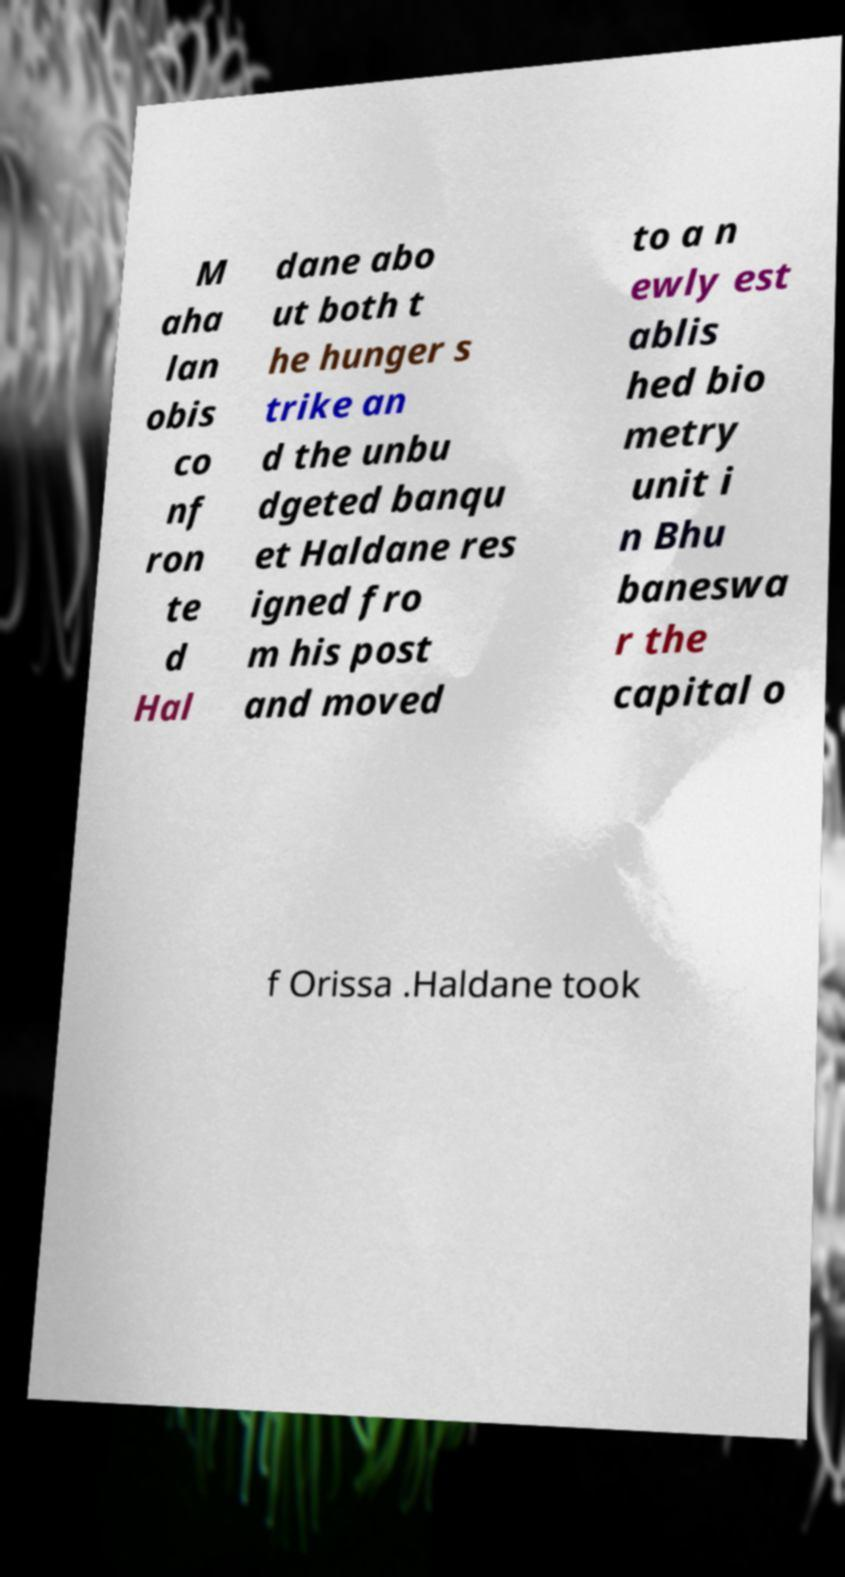What messages or text are displayed in this image? I need them in a readable, typed format. M aha lan obis co nf ron te d Hal dane abo ut both t he hunger s trike an d the unbu dgeted banqu et Haldane res igned fro m his post and moved to a n ewly est ablis hed bio metry unit i n Bhu baneswa r the capital o f Orissa .Haldane took 